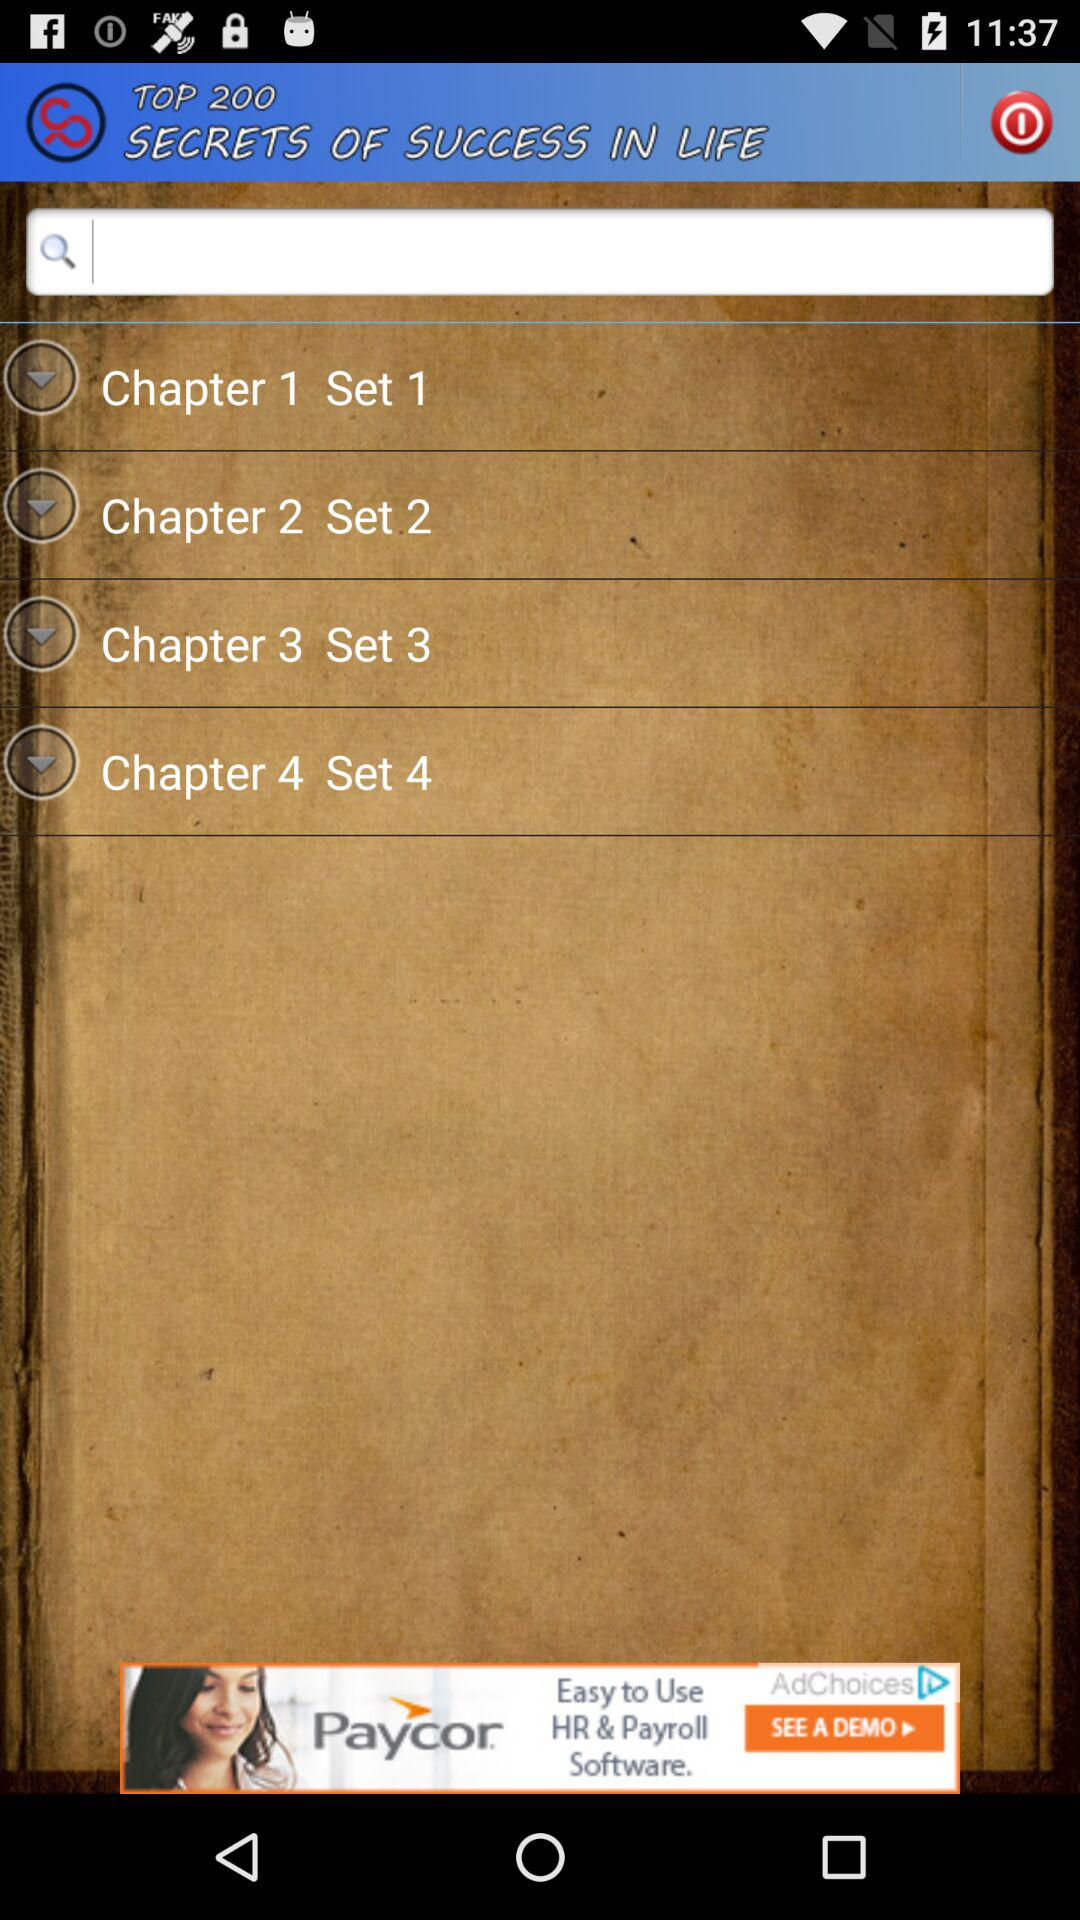What is the name of the application? The name of the application is "TOP 200 SECRETS OF SUCCESS IN LIFE". 